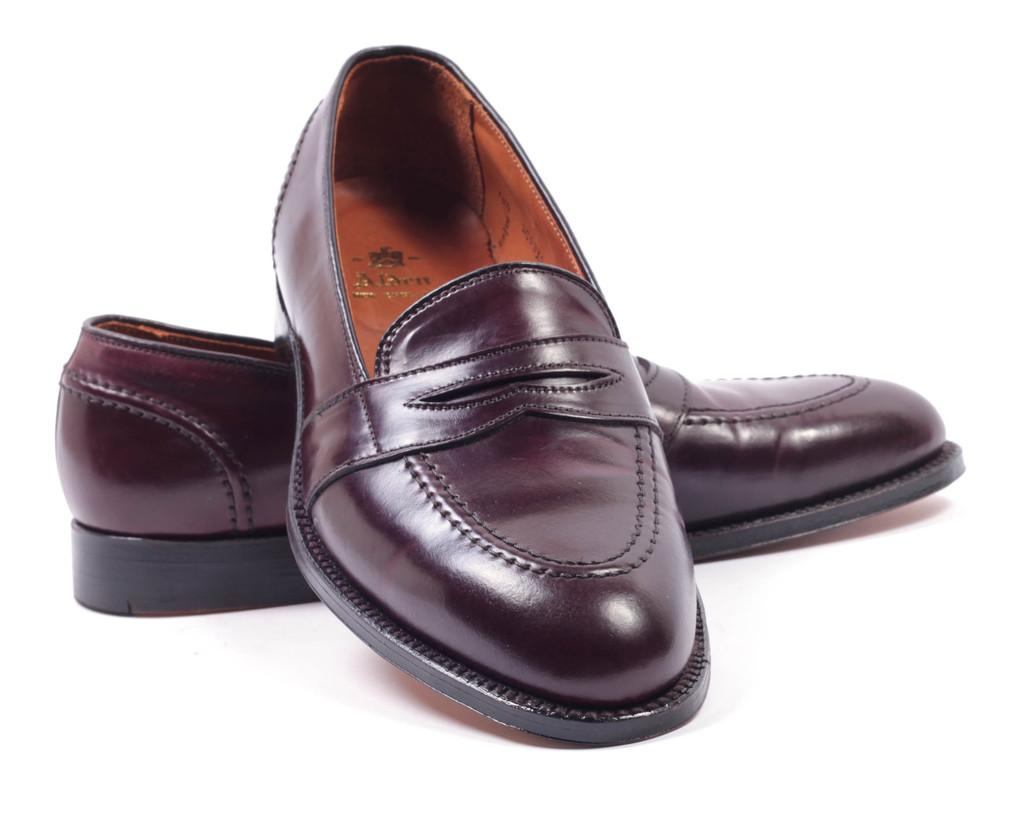What type of object is in the image? There is a pair of shoes in the image. What is the shoes placed on? The shoes are on a white surface. What force is being applied to the shoes in the image? There is no force being applied to the shoes in the image; they are simply placed on the white surface. 